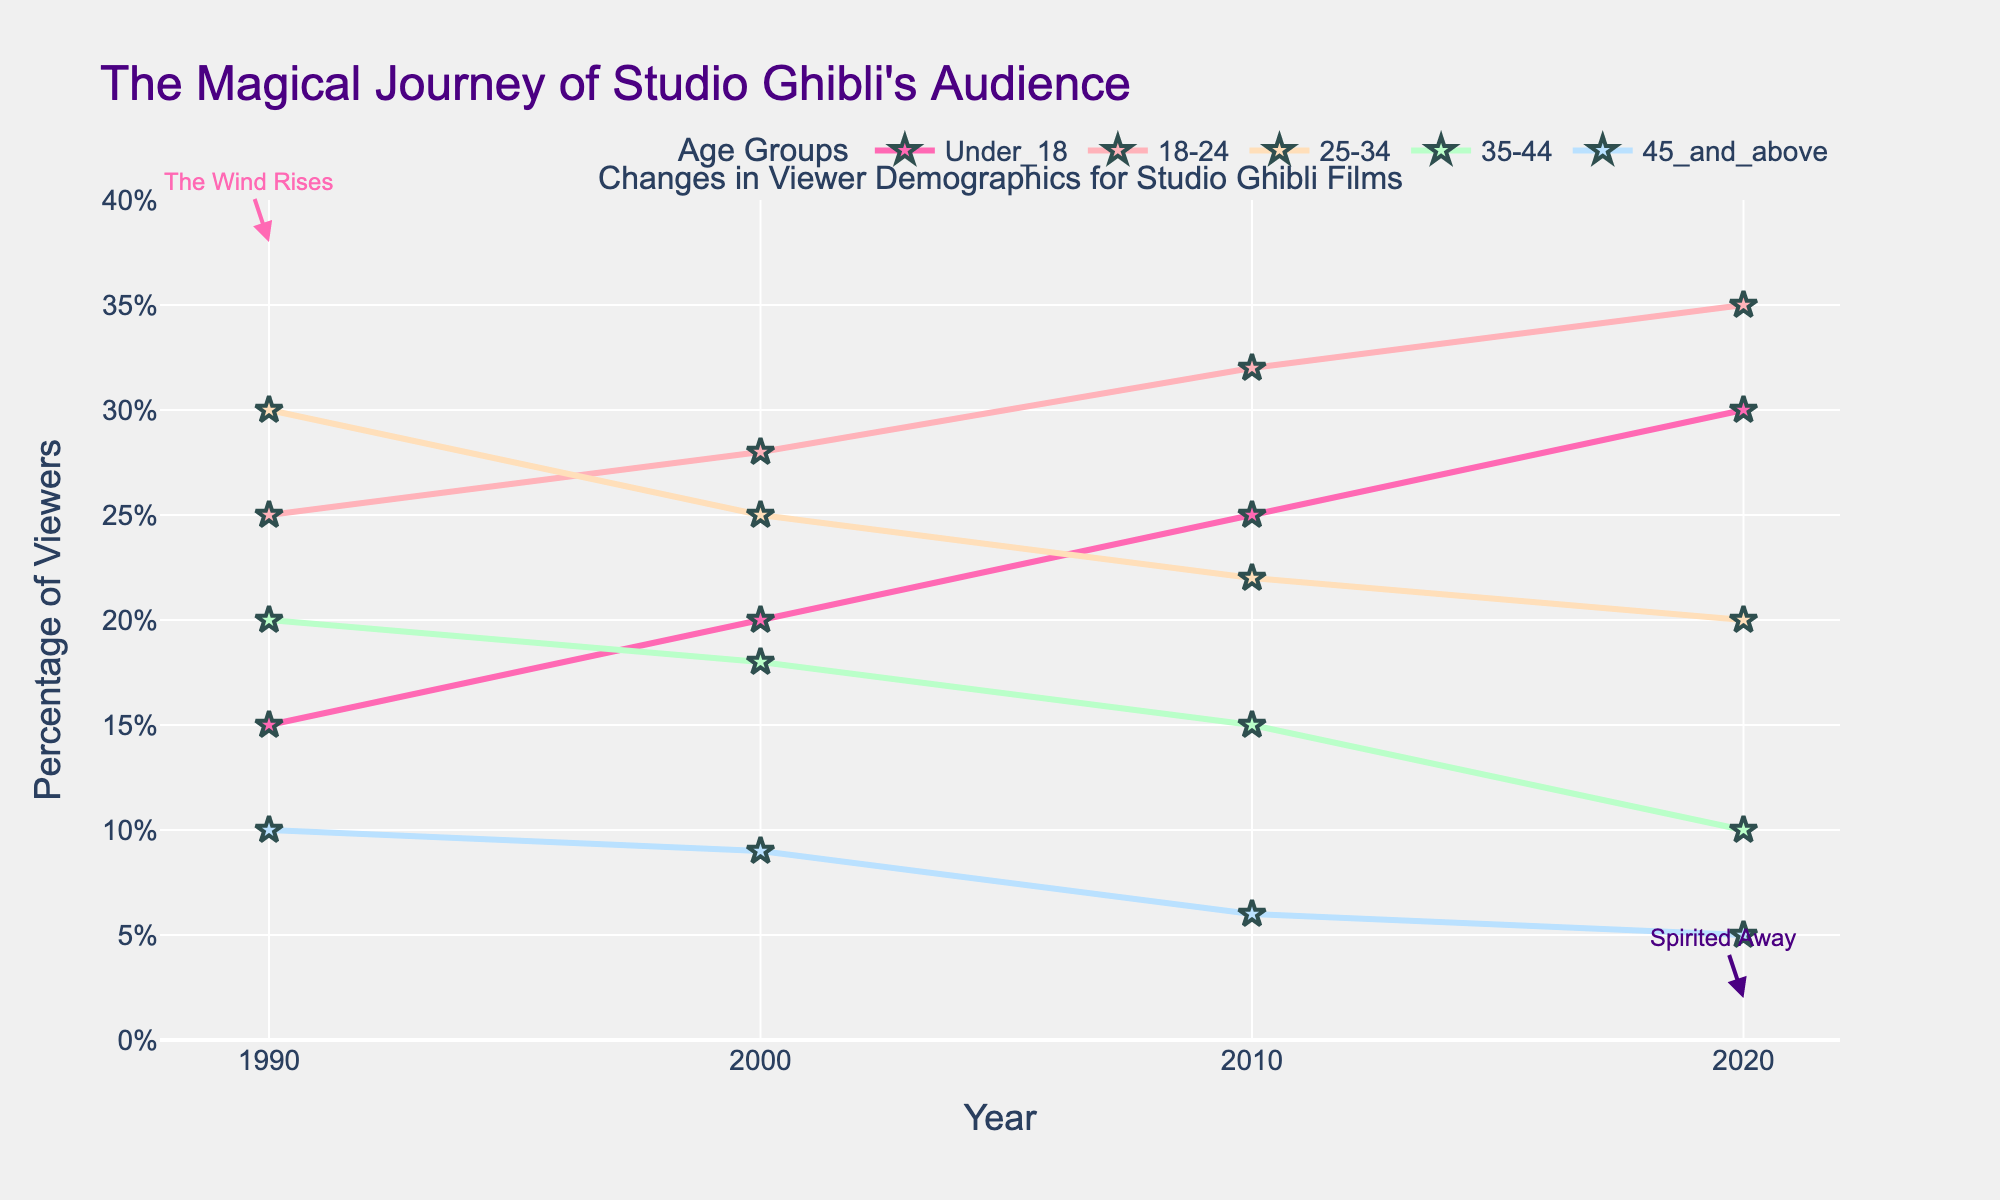What's the title of the figure? The title is displayed at the top of the figure. It reads "The Magical Journey of Studio Ghibli's Audience".
Answer: The Magical Journey of Studio Ghibli's Audience In which year did the age group "Under_18" have the highest percentage of viewers? Look for the highest point on the line representing "Under_18". This occurs in 2020.
Answer: 2020 Compare the percentage of viewers aged "35-44" in 1990 and 2020. Which year had a higher percentage? Find the data points for "35-44" in both 1990 and 2020. In 1990, it's 20%, while in 2020, it's 10%. Thus, 1990 had a higher percentage.
Answer: 1990 What is the difference in the percentage of viewers aged "18-24" between the years 2000 and 2020? Find the percentage of "18-24" in 2000 (28%) and in 2020 (35%), then subtract the former from the latter: 35% - 28% = 7%.
Answer: 7% Which age group shows a declining trend from 1990 to 2020? Observe the trends of each age group. The "45_and_above" group consistently drops from 10% in 1990 to 5% in 2020.
Answer: 45_and_above What is the average percentage of viewers for the age group "25-34" over the four decades? Find values: 30% (1990), 25% (2000), 22% (2010), and 20% (2020). Sum them (30 + 25 + 22 + 20 = 97) and divide by 4: 97 / 4 = 24.25%.
Answer: 24.25% Which two age groups had an increase in viewer percentage from 1990 to 2000? Compare the values between 1990 and 2000 for all age groups. Both "Under_18" (15% to 20%) and "18-24" (25% to 28%) show an increase.
Answer: Under_18 and 18-24 How many age groups are represented in the figure? The legend at the bottom of the figure lists all age groups. There are five groups: "Under_18", "18-24", "25-34", "35-44", and "45_and_above".
Answer: 5 In which year did "35-44" age group have its lowest percentage of viewers? Check the percentage values for "35-44" across the years. The lowest value is 10% in 2020.
Answer: 2020 What is the sum of the percentage of viewers for all age groups in 2010? Add the percentages for all age groups in 2010: 25% (Under_18) + 32% (18-24) + 22% (25-34) + 15% (35-44) + 6% (45_and_above) = 100%.
Answer: 100% 